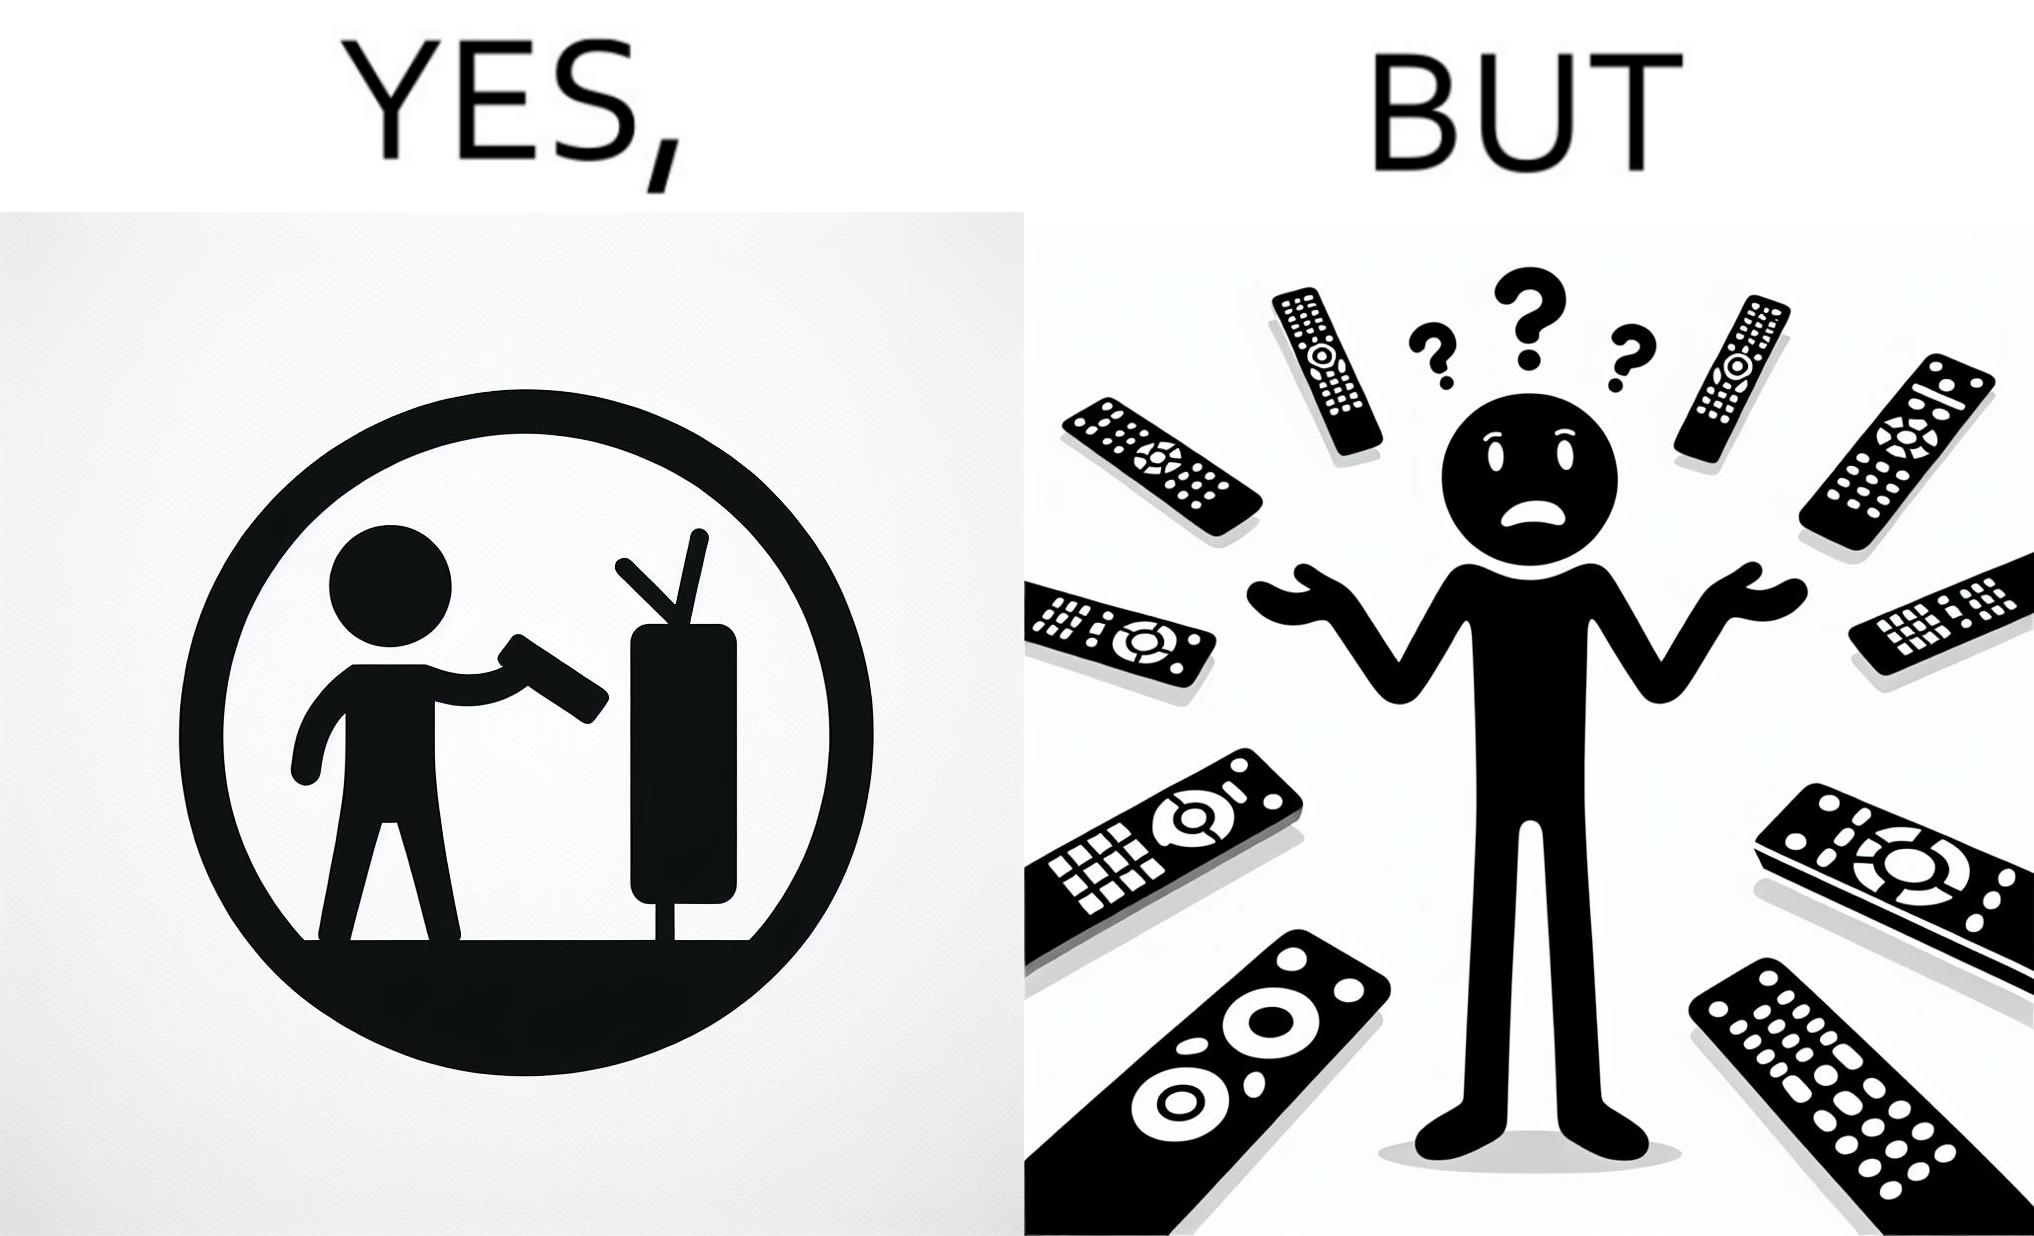Describe the contrast between the left and right parts of this image. In the left part of the image: It is a remote being used to operate a TV In the right part of the image: It is an user confused between multiple remotes 